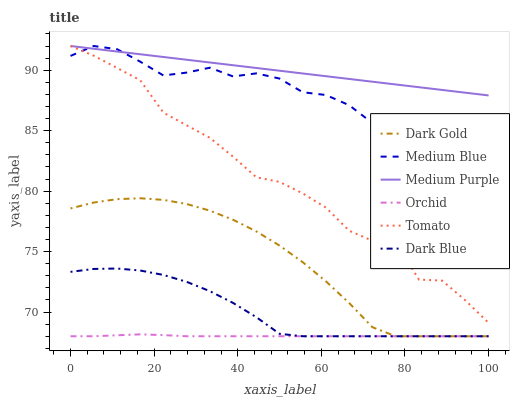Does Orchid have the minimum area under the curve?
Answer yes or no. Yes. Does Medium Purple have the maximum area under the curve?
Answer yes or no. Yes. Does Dark Gold have the minimum area under the curve?
Answer yes or no. No. Does Dark Gold have the maximum area under the curve?
Answer yes or no. No. Is Medium Purple the smoothest?
Answer yes or no. Yes. Is Tomato the roughest?
Answer yes or no. Yes. Is Dark Gold the smoothest?
Answer yes or no. No. Is Dark Gold the roughest?
Answer yes or no. No. Does Dark Gold have the lowest value?
Answer yes or no. Yes. Does Medium Blue have the lowest value?
Answer yes or no. No. Does Medium Purple have the highest value?
Answer yes or no. Yes. Does Dark Gold have the highest value?
Answer yes or no. No. Is Dark Gold less than Medium Purple?
Answer yes or no. Yes. Is Tomato greater than Dark Gold?
Answer yes or no. Yes. Does Tomato intersect Medium Purple?
Answer yes or no. Yes. Is Tomato less than Medium Purple?
Answer yes or no. No. Is Tomato greater than Medium Purple?
Answer yes or no. No. Does Dark Gold intersect Medium Purple?
Answer yes or no. No. 